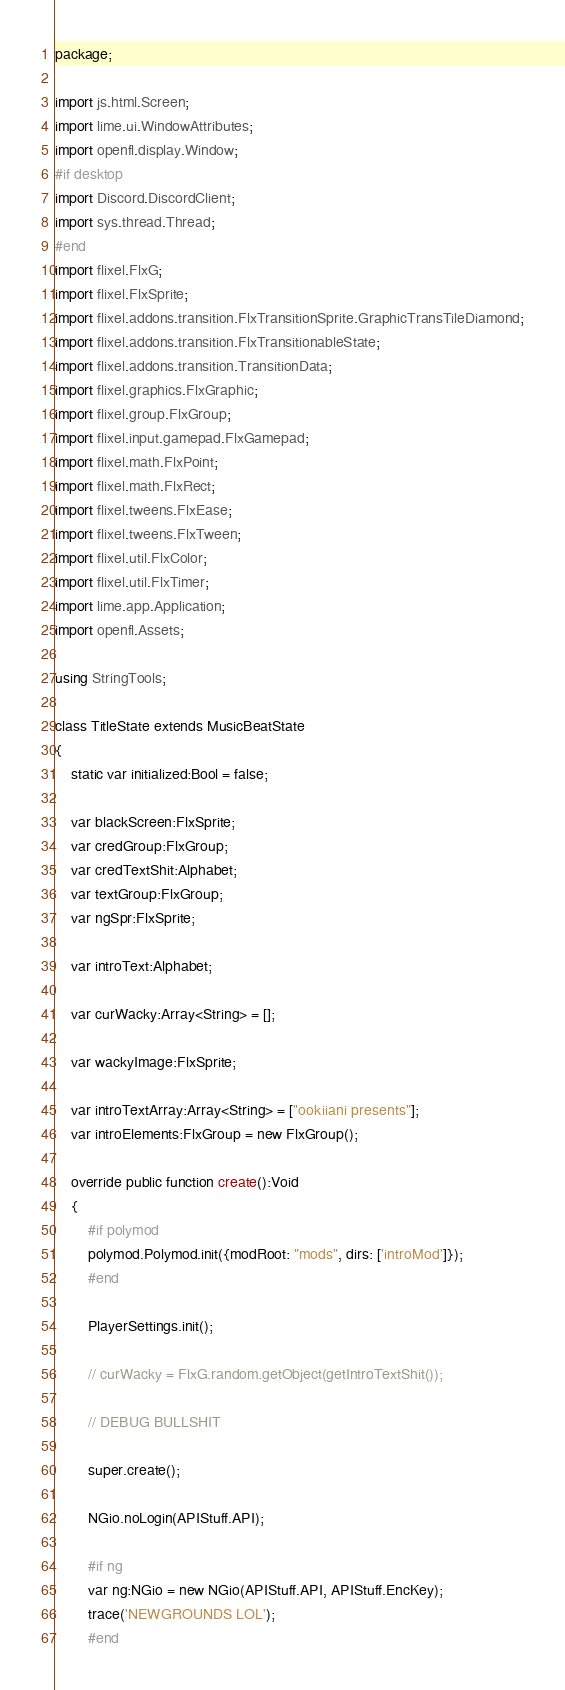Convert code to text. <code><loc_0><loc_0><loc_500><loc_500><_Haxe_>package;

import js.html.Screen;
import lime.ui.WindowAttributes;
import openfl.display.Window;
#if desktop
import Discord.DiscordClient;
import sys.thread.Thread;
#end
import flixel.FlxG;
import flixel.FlxSprite;
import flixel.addons.transition.FlxTransitionSprite.GraphicTransTileDiamond;
import flixel.addons.transition.FlxTransitionableState;
import flixel.addons.transition.TransitionData;
import flixel.graphics.FlxGraphic;
import flixel.group.FlxGroup;
import flixel.input.gamepad.FlxGamepad;
import flixel.math.FlxPoint;
import flixel.math.FlxRect;
import flixel.tweens.FlxEase;
import flixel.tweens.FlxTween;
import flixel.util.FlxColor;
import flixel.util.FlxTimer;
import lime.app.Application;
import openfl.Assets;

using StringTools;

class TitleState extends MusicBeatState
{
	static var initialized:Bool = false;

	var blackScreen:FlxSprite;
	var credGroup:FlxGroup;
	var credTextShit:Alphabet;
	var textGroup:FlxGroup;
	var ngSpr:FlxSprite;

	var introText:Alphabet;

	var curWacky:Array<String> = [];

	var wackyImage:FlxSprite;

	var introTextArray:Array<String> = ["ookiiani presents"];
	var introElements:FlxGroup = new FlxGroup();

	override public function create():Void
	{
		#if polymod
		polymod.Polymod.init({modRoot: "mods", dirs: ['introMod']});
		#end

		PlayerSettings.init();

		// curWacky = FlxG.random.getObject(getIntroTextShit());

		// DEBUG BULLSHIT

		super.create();

		NGio.noLogin(APIStuff.API);

		#if ng
		var ng:NGio = new NGio(APIStuff.API, APIStuff.EncKey);
		trace('NEWGROUNDS LOL');
		#end
</code> 